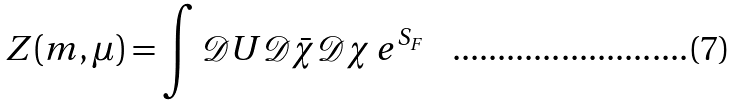Convert formula to latex. <formula><loc_0><loc_0><loc_500><loc_500>Z ( m , \mu ) = \int \mathcal { D } U \mathcal { D } \bar { \chi } \mathcal { D } \chi \, e ^ { S _ { F } }</formula> 